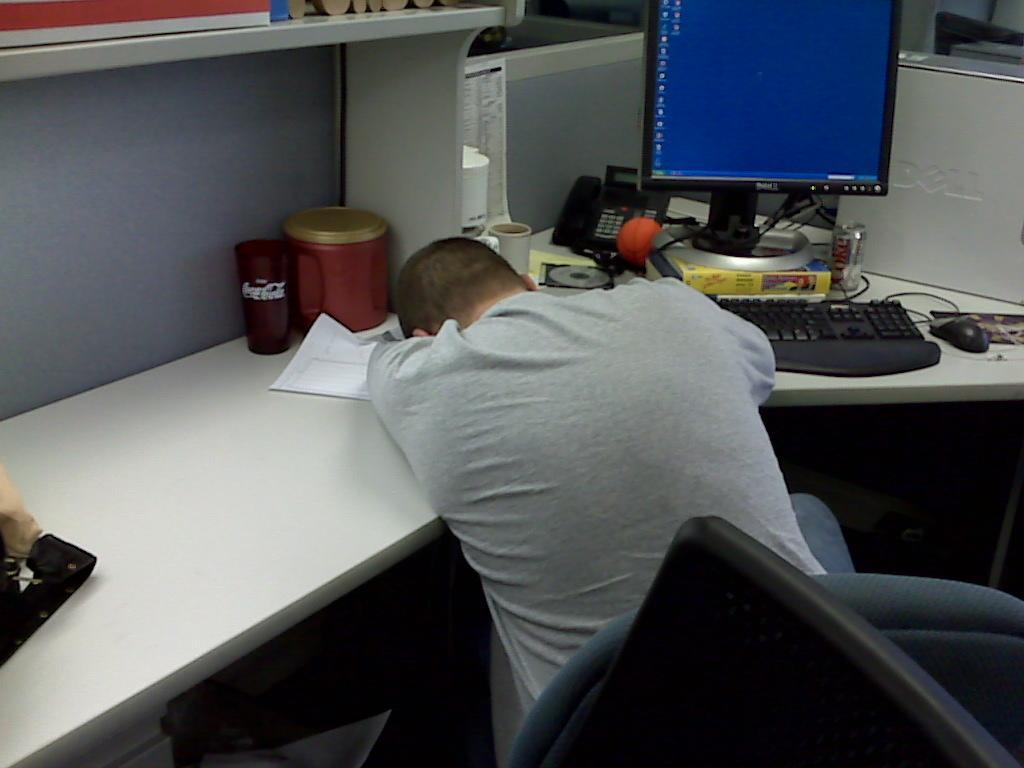Describe this image in one or two sentences. In this picture we can see a table and there is a glass and container, paper , keyboard, mouse , telephone on the table. This is a cabin. here we can see a paper note and a monitor screen. Here we can see one person sitting on the chair and laid his head on the table. 